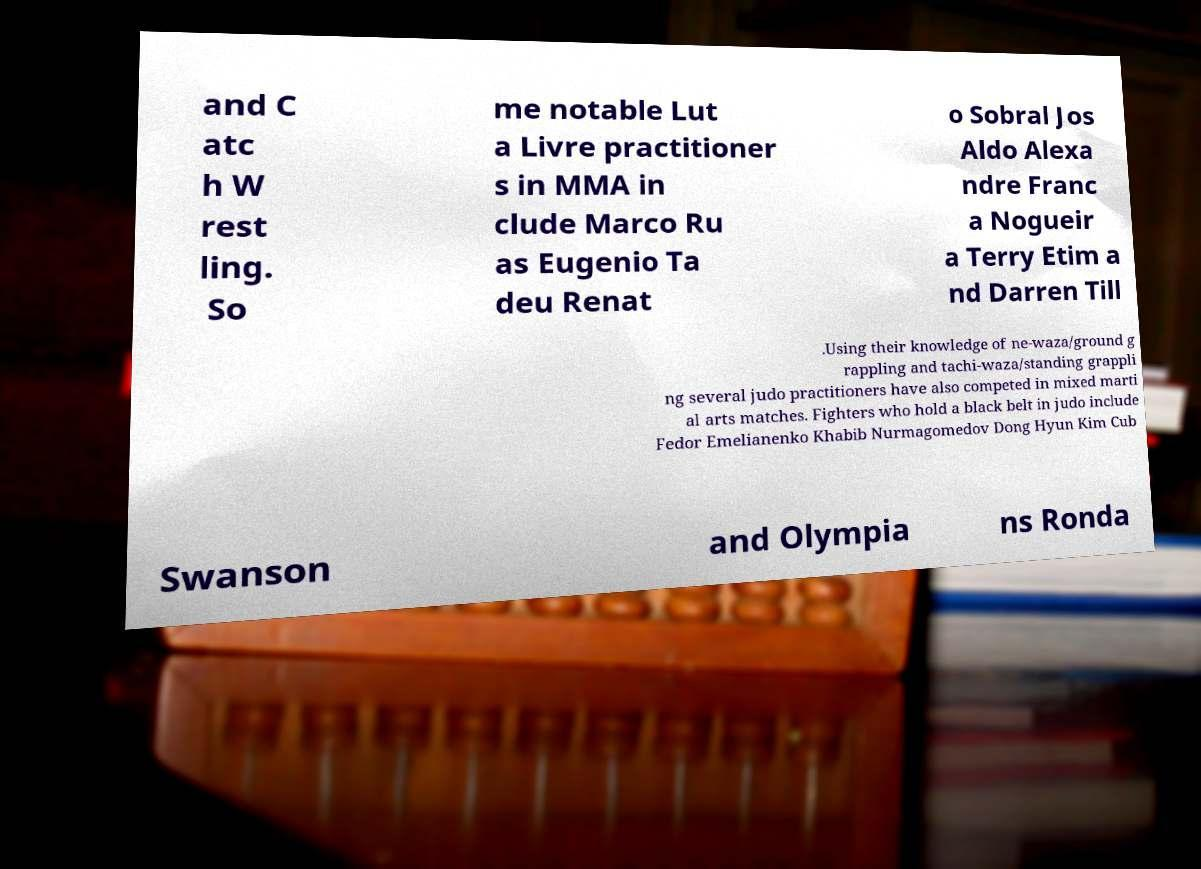Could you assist in decoding the text presented in this image and type it out clearly? and C atc h W rest ling. So me notable Lut a Livre practitioner s in MMA in clude Marco Ru as Eugenio Ta deu Renat o Sobral Jos Aldo Alexa ndre Franc a Nogueir a Terry Etim a nd Darren Till .Using their knowledge of ne-waza/ground g rappling and tachi-waza/standing grappli ng several judo practitioners have also competed in mixed marti al arts matches. Fighters who hold a black belt in judo include Fedor Emelianenko Khabib Nurmagomedov Dong Hyun Kim Cub Swanson and Olympia ns Ronda 